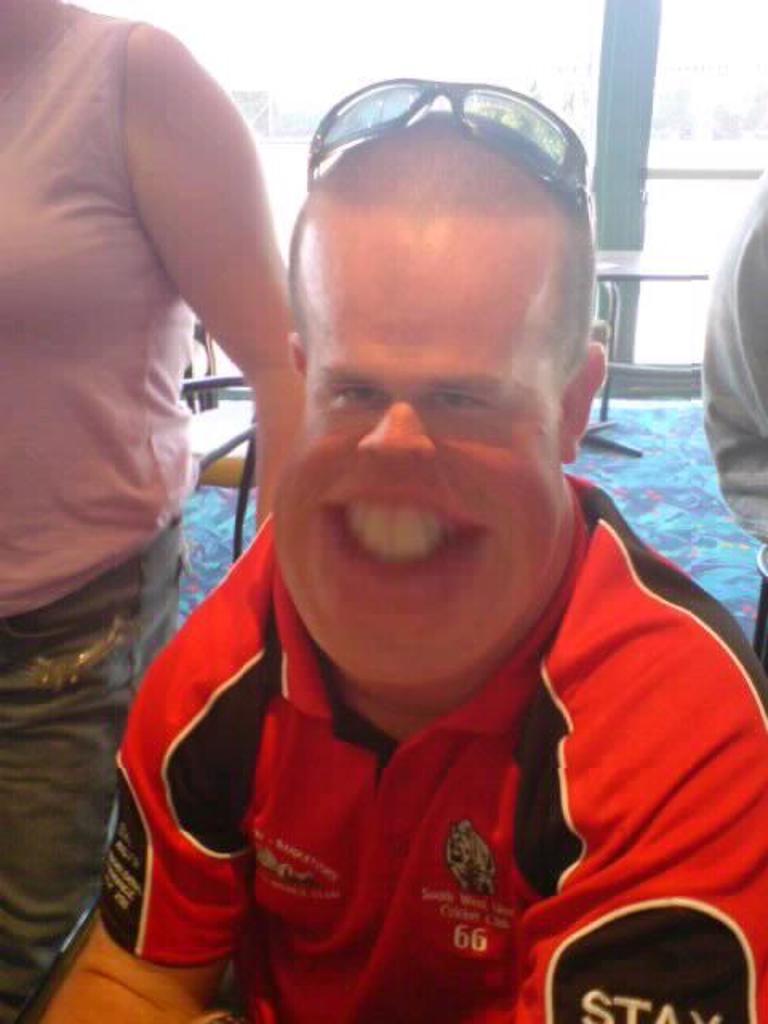How would you summarize this image in a sentence or two? This is an edited image, in this image there is a person sitting on a chair, on either side of him there are two people standing, in the background there is a table and a pole. 